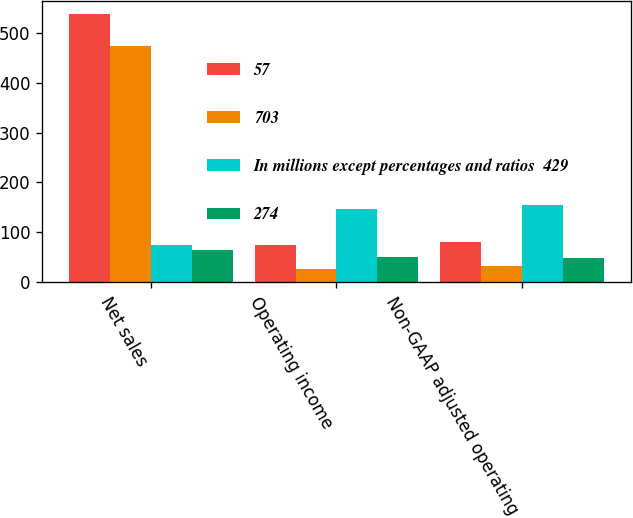Convert chart. <chart><loc_0><loc_0><loc_500><loc_500><stacked_bar_chart><ecel><fcel>Net sales<fcel>Operating income<fcel>Non-GAAP adjusted operating<nl><fcel>57<fcel>538<fcel>74<fcel>80<nl><fcel>703<fcel>473<fcel>25<fcel>32<nl><fcel>In millions except percentages and ratios  429<fcel>74<fcel>147<fcel>154<nl><fcel>274<fcel>65<fcel>49<fcel>48<nl></chart> 